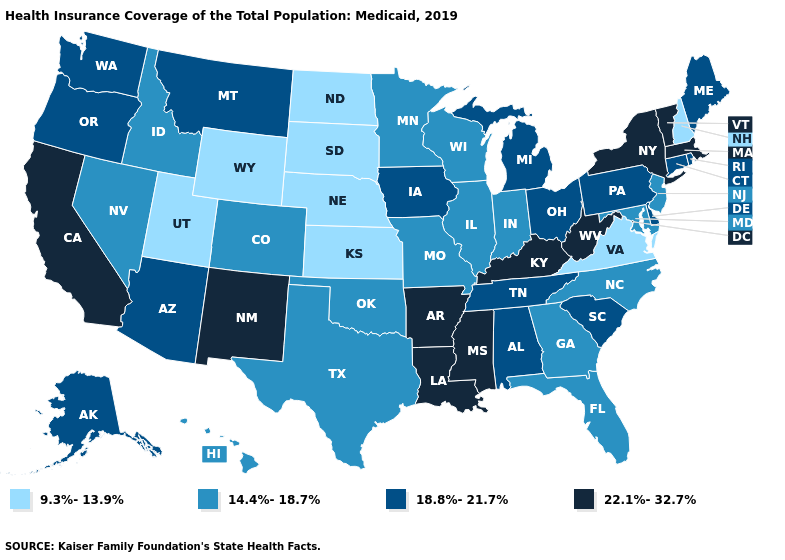Name the states that have a value in the range 9.3%-13.9%?
Give a very brief answer. Kansas, Nebraska, New Hampshire, North Dakota, South Dakota, Utah, Virginia, Wyoming. What is the value of Indiana?
Keep it brief. 14.4%-18.7%. What is the lowest value in the West?
Be succinct. 9.3%-13.9%. What is the value of Indiana?
Concise answer only. 14.4%-18.7%. What is the value of Arkansas?
Concise answer only. 22.1%-32.7%. What is the value of Florida?
Keep it brief. 14.4%-18.7%. Name the states that have a value in the range 9.3%-13.9%?
Quick response, please. Kansas, Nebraska, New Hampshire, North Dakota, South Dakota, Utah, Virginia, Wyoming. Does Ohio have the highest value in the USA?
Short answer required. No. Does Colorado have the highest value in the West?
Write a very short answer. No. Name the states that have a value in the range 14.4%-18.7%?
Answer briefly. Colorado, Florida, Georgia, Hawaii, Idaho, Illinois, Indiana, Maryland, Minnesota, Missouri, Nevada, New Jersey, North Carolina, Oklahoma, Texas, Wisconsin. Which states have the lowest value in the USA?
Write a very short answer. Kansas, Nebraska, New Hampshire, North Dakota, South Dakota, Utah, Virginia, Wyoming. What is the value of North Carolina?
Give a very brief answer. 14.4%-18.7%. What is the value of Tennessee?
Keep it brief. 18.8%-21.7%. Among the states that border Montana , does Wyoming have the lowest value?
Write a very short answer. Yes. Name the states that have a value in the range 22.1%-32.7%?
Short answer required. Arkansas, California, Kentucky, Louisiana, Massachusetts, Mississippi, New Mexico, New York, Vermont, West Virginia. 